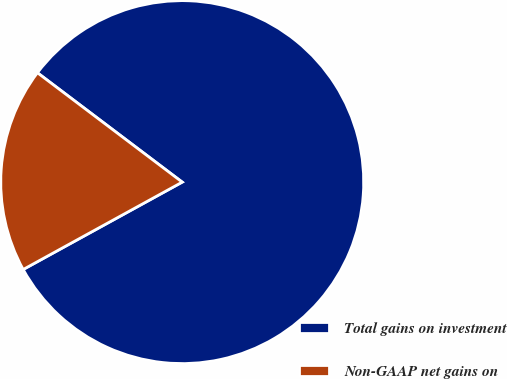<chart> <loc_0><loc_0><loc_500><loc_500><pie_chart><fcel>Total gains on investment<fcel>Non-GAAP net gains on<nl><fcel>81.71%<fcel>18.29%<nl></chart> 